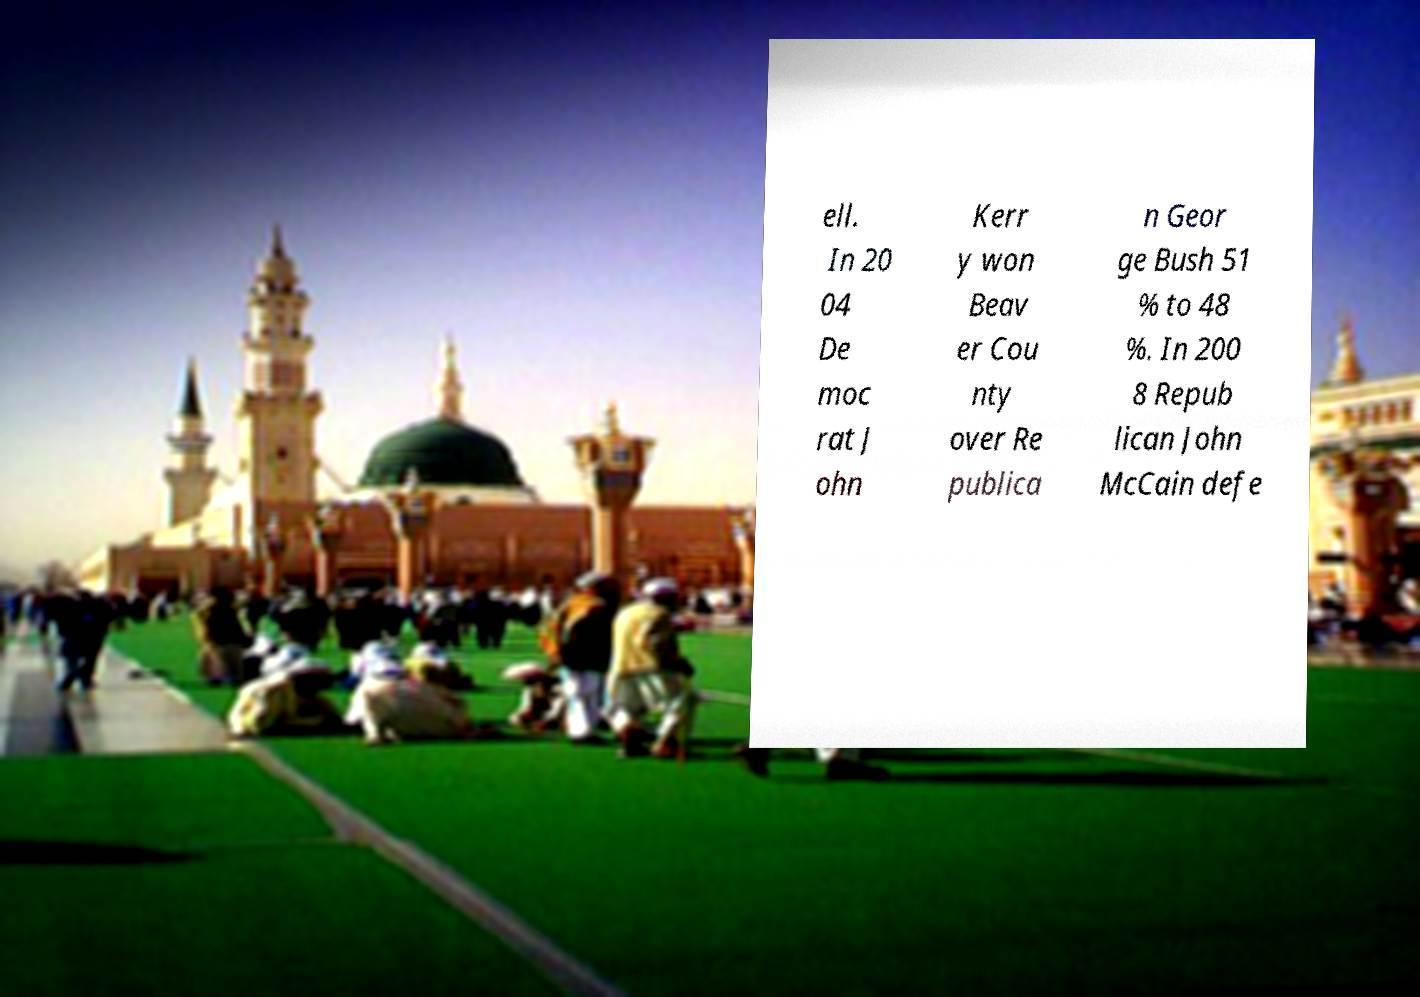For documentation purposes, I need the text within this image transcribed. Could you provide that? ell. In 20 04 De moc rat J ohn Kerr y won Beav er Cou nty over Re publica n Geor ge Bush 51 % to 48 %. In 200 8 Repub lican John McCain defe 